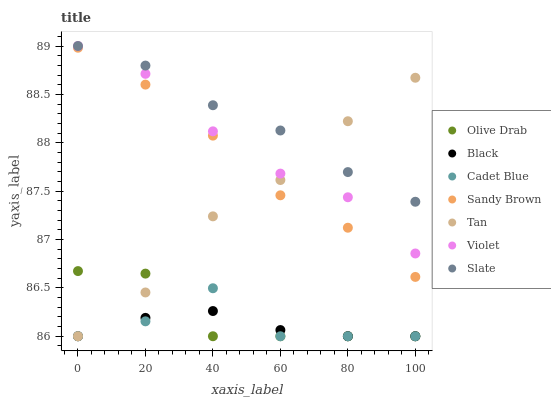Does Black have the minimum area under the curve?
Answer yes or no. Yes. Does Slate have the maximum area under the curve?
Answer yes or no. Yes. Does Slate have the minimum area under the curve?
Answer yes or no. No. Does Black have the maximum area under the curve?
Answer yes or no. No. Is Black the smoothest?
Answer yes or no. Yes. Is Cadet Blue the roughest?
Answer yes or no. Yes. Is Slate the smoothest?
Answer yes or no. No. Is Slate the roughest?
Answer yes or no. No. Does Cadet Blue have the lowest value?
Answer yes or no. Yes. Does Slate have the lowest value?
Answer yes or no. No. Does Violet have the highest value?
Answer yes or no. Yes. Does Black have the highest value?
Answer yes or no. No. Is Black less than Sandy Brown?
Answer yes or no. Yes. Is Slate greater than Black?
Answer yes or no. Yes. Does Tan intersect Sandy Brown?
Answer yes or no. Yes. Is Tan less than Sandy Brown?
Answer yes or no. No. Is Tan greater than Sandy Brown?
Answer yes or no. No. Does Black intersect Sandy Brown?
Answer yes or no. No. 